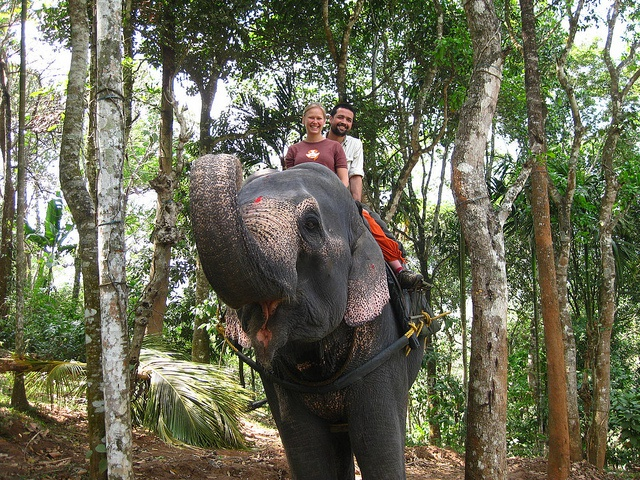Describe the objects in this image and their specific colors. I can see elephant in tan, black, gray, and darkgray tones, people in tan, brown, maroon, and lightpink tones, and people in tan, white, black, and gray tones in this image. 